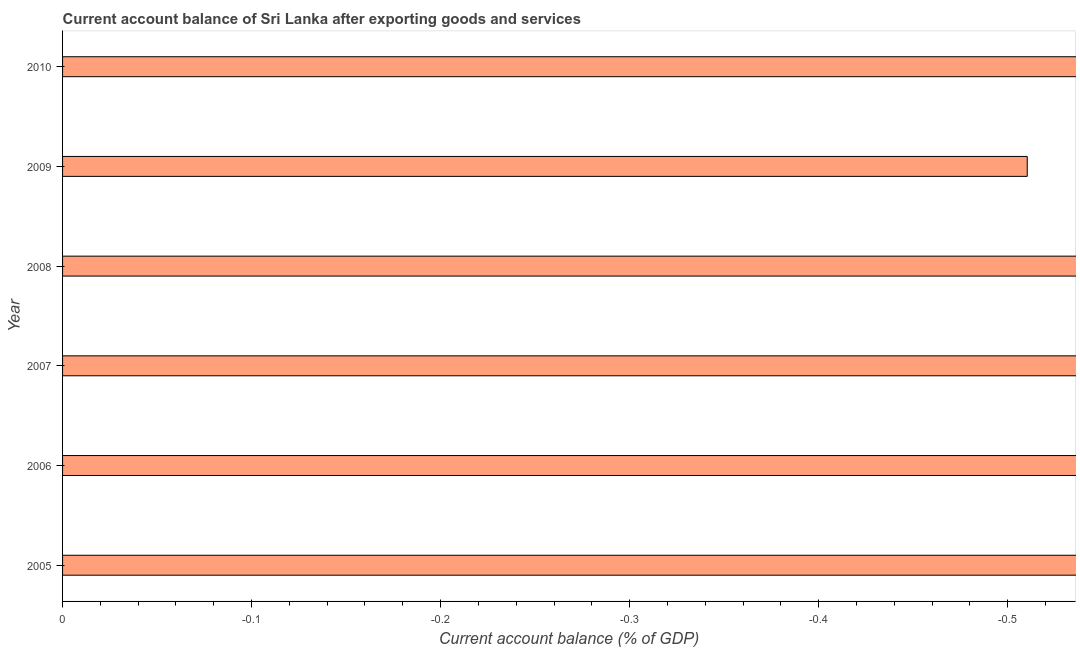Does the graph contain any zero values?
Provide a short and direct response. Yes. Does the graph contain grids?
Give a very brief answer. No. What is the title of the graph?
Offer a very short reply. Current account balance of Sri Lanka after exporting goods and services. What is the label or title of the X-axis?
Provide a short and direct response. Current account balance (% of GDP). What is the label or title of the Y-axis?
Offer a terse response. Year. Across all years, what is the minimum current account balance?
Make the answer very short. 0. What is the median current account balance?
Your answer should be very brief. 0. In how many years, is the current account balance greater than the average current account balance taken over all years?
Keep it short and to the point. 0. Are all the bars in the graph horizontal?
Offer a terse response. Yes. What is the difference between two consecutive major ticks on the X-axis?
Ensure brevity in your answer.  0.1. What is the Current account balance (% of GDP) in 2005?
Your answer should be compact. 0. What is the Current account balance (% of GDP) of 2006?
Ensure brevity in your answer.  0. What is the Current account balance (% of GDP) of 2008?
Ensure brevity in your answer.  0. 